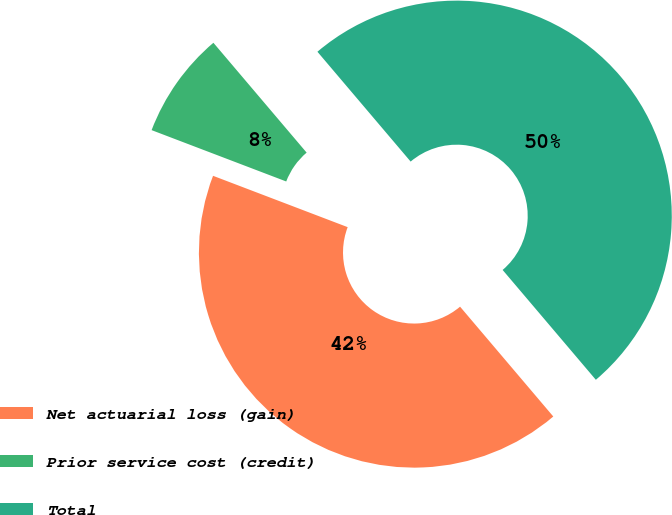Convert chart to OTSL. <chart><loc_0><loc_0><loc_500><loc_500><pie_chart><fcel>Net actuarial loss (gain)<fcel>Prior service cost (credit)<fcel>Total<nl><fcel>42.0%<fcel>8.0%<fcel>50.0%<nl></chart> 